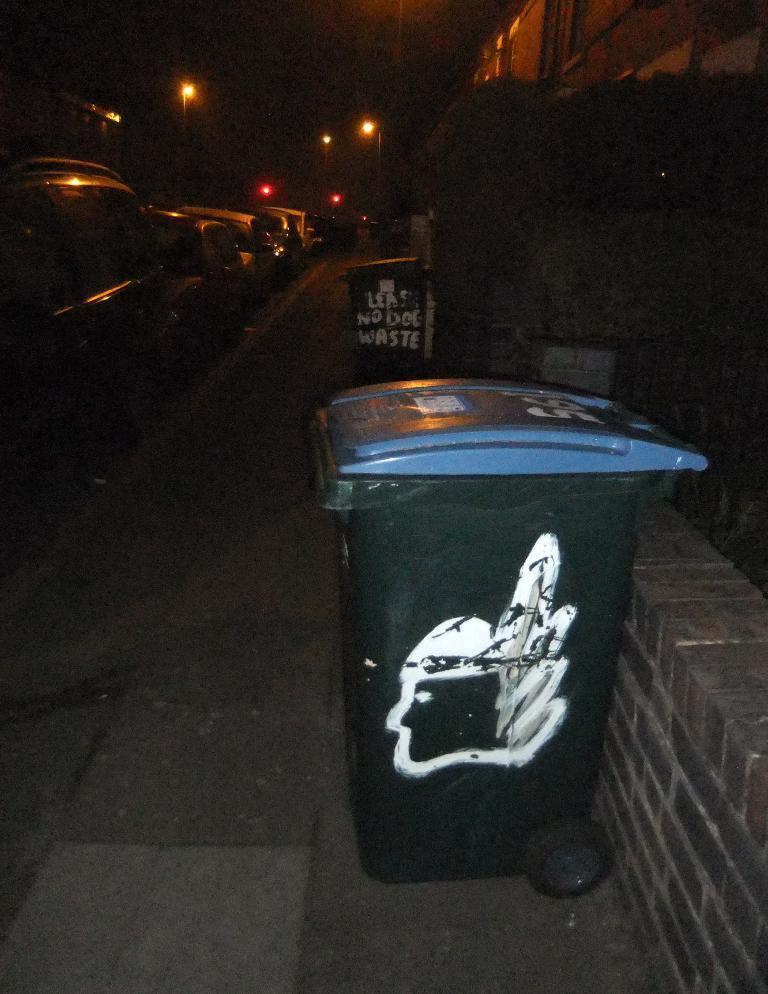How would you summarize this image in a sentence or two? In this image there is a footpath on which there are two dustbins. Beside the footpath there is a road on which there are cars. In the background there are street lights. This image is taken during the night time. 